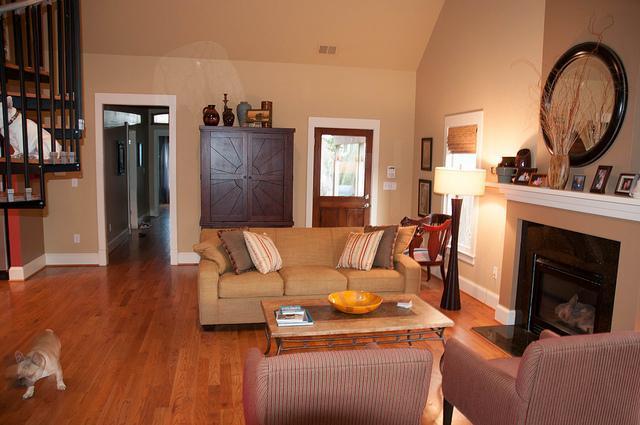How many books are on the end table?
Give a very brief answer. 3. How many couches can you see?
Give a very brief answer. 2. How many chairs are there?
Give a very brief answer. 2. 